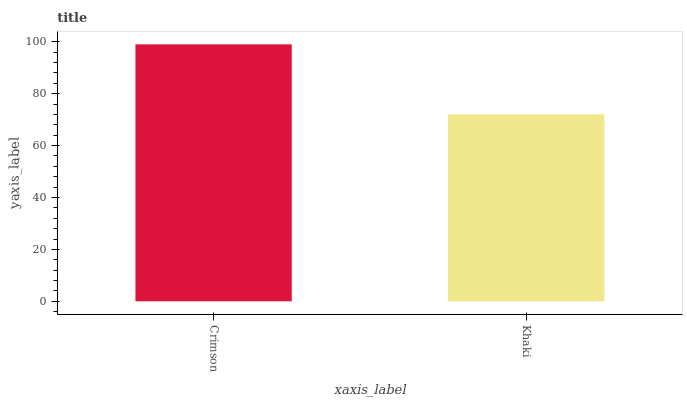Is Khaki the minimum?
Answer yes or no. Yes. Is Crimson the maximum?
Answer yes or no. Yes. Is Khaki the maximum?
Answer yes or no. No. Is Crimson greater than Khaki?
Answer yes or no. Yes. Is Khaki less than Crimson?
Answer yes or no. Yes. Is Khaki greater than Crimson?
Answer yes or no. No. Is Crimson less than Khaki?
Answer yes or no. No. Is Crimson the high median?
Answer yes or no. Yes. Is Khaki the low median?
Answer yes or no. Yes. Is Khaki the high median?
Answer yes or no. No. Is Crimson the low median?
Answer yes or no. No. 